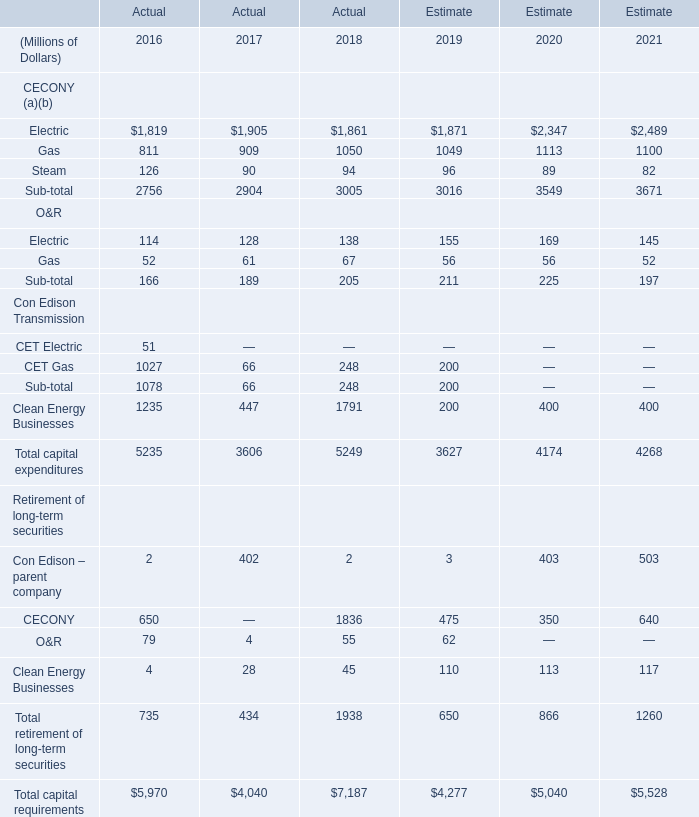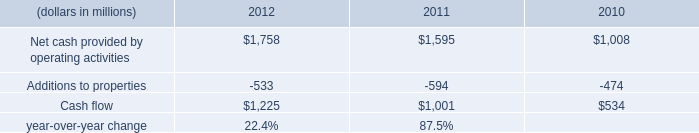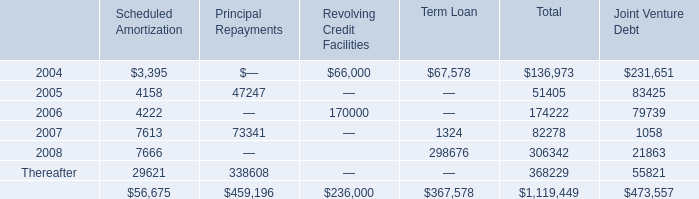In the year with lowest amount of CECONY's Actual Electric, what's the increasing rate of CECONY's Actual Steam? 
Computations: ((126 - 90) / 90)
Answer: 0.4. What is the average amount of Net cash provided by operating activities of 2010, and Electric of Estimate 2021 ? 
Computations: ((1008.0 + 2489.0) / 2)
Answer: 1748.5. 